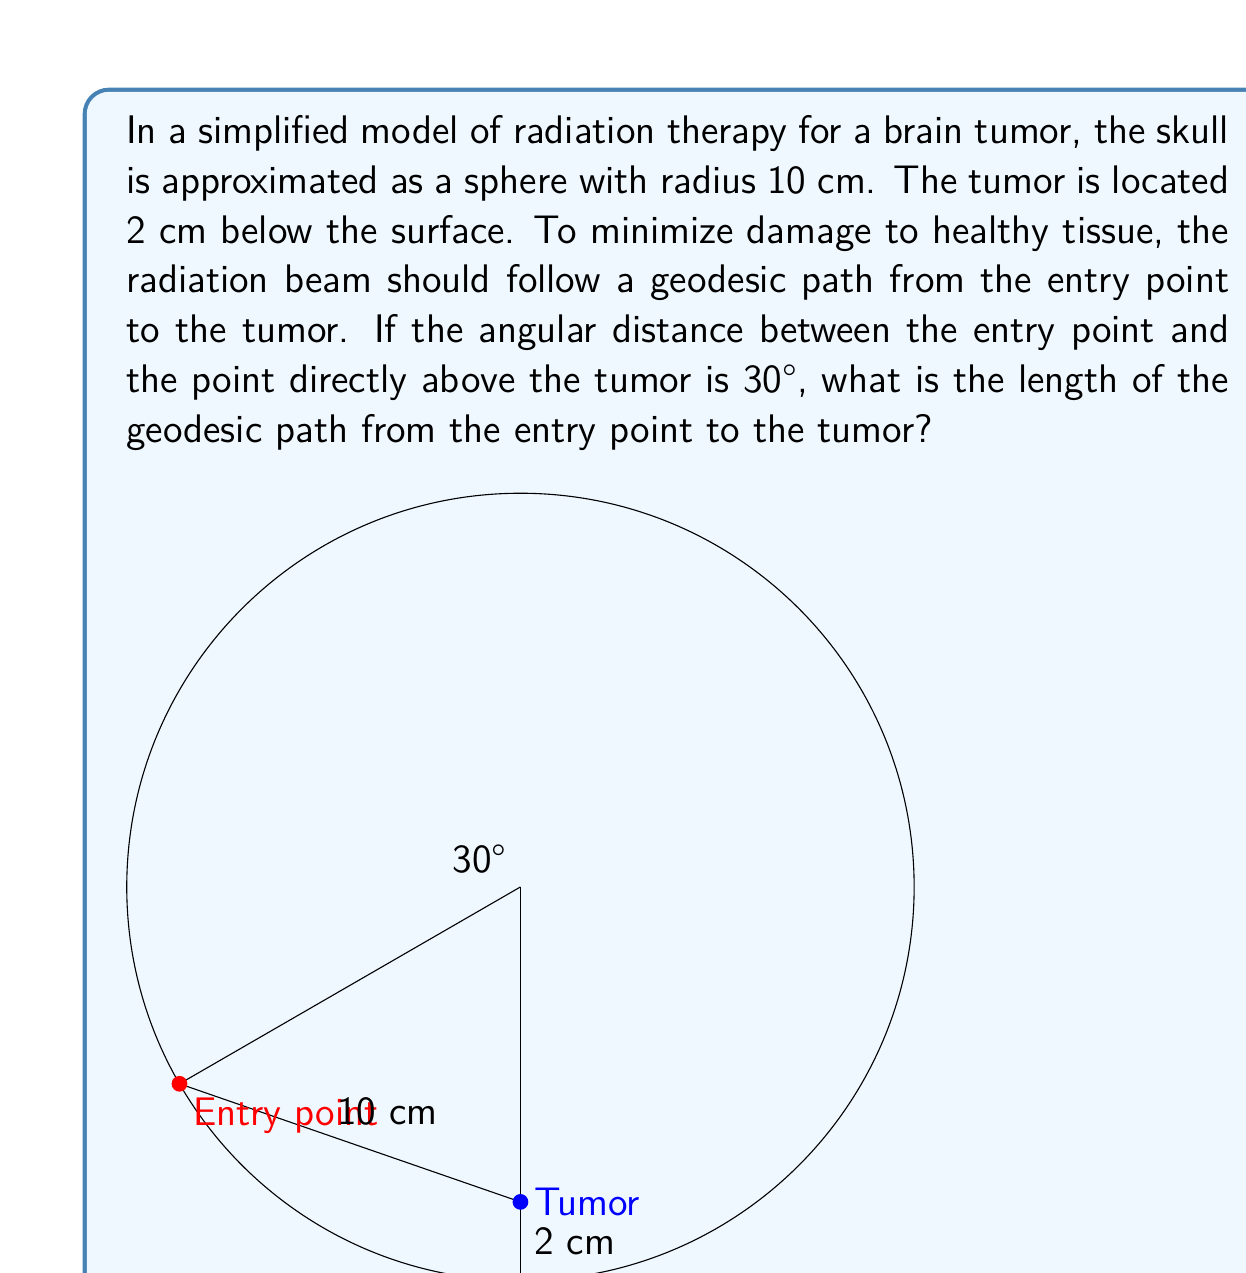Solve this math problem. Let's approach this step-by-step:

1) In spherical geometry, the geodesic between two points is the great circle arc connecting them.

2) The length of a great circle arc is given by $s = R\theta$, where $R$ is the radius of the sphere and $\theta$ is the central angle in radians.

3) We're given that the angular distance is 30°. We need to convert this to radians:
   $\theta = 30° \times \frac{\pi}{180°} = \frac{\pi}{6}$ radians

4) The radius of the sphere (skull) is 10 cm. So the length of the great circle arc on the surface is:
   $s = R\theta = 10 \times \frac{\pi}{6} = \frac{5\pi}{3}$ cm

5) However, the tumor is 2 cm below the surface. We need to find the length of the chord from the entry point to the tumor.

6) Let's call the center of the sphere O, the entry point A, and the tumor T. We now have a right-angled triangle OAT.

7) In this triangle:
   OA = 10 cm (radius of the sphere)
   OT = 8 cm (radius minus depth of tumor)
   Angle AOT = 30°

8) We can use the law of cosines to find AT:
   $AT^2 = OA^2 + OT^2 - 2(OA)(OT)\cos(30°)$

9) Substituting the values:
   $AT^2 = 10^2 + 8^2 - 2(10)(8)\cos(30°)$
   $AT^2 = 100 + 64 - 160\cos(30°)$
   $AT^2 = 164 - 160 \times \frac{\sqrt{3}}{2}$
   $AT^2 = 164 - 80\sqrt{3}$

10) Taking the square root:
    $AT = \sqrt{164 - 80\sqrt{3}}$ cm

This is the length of the geodesic path from the entry point to the tumor.
Answer: $\sqrt{164 - 80\sqrt{3}}$ cm 